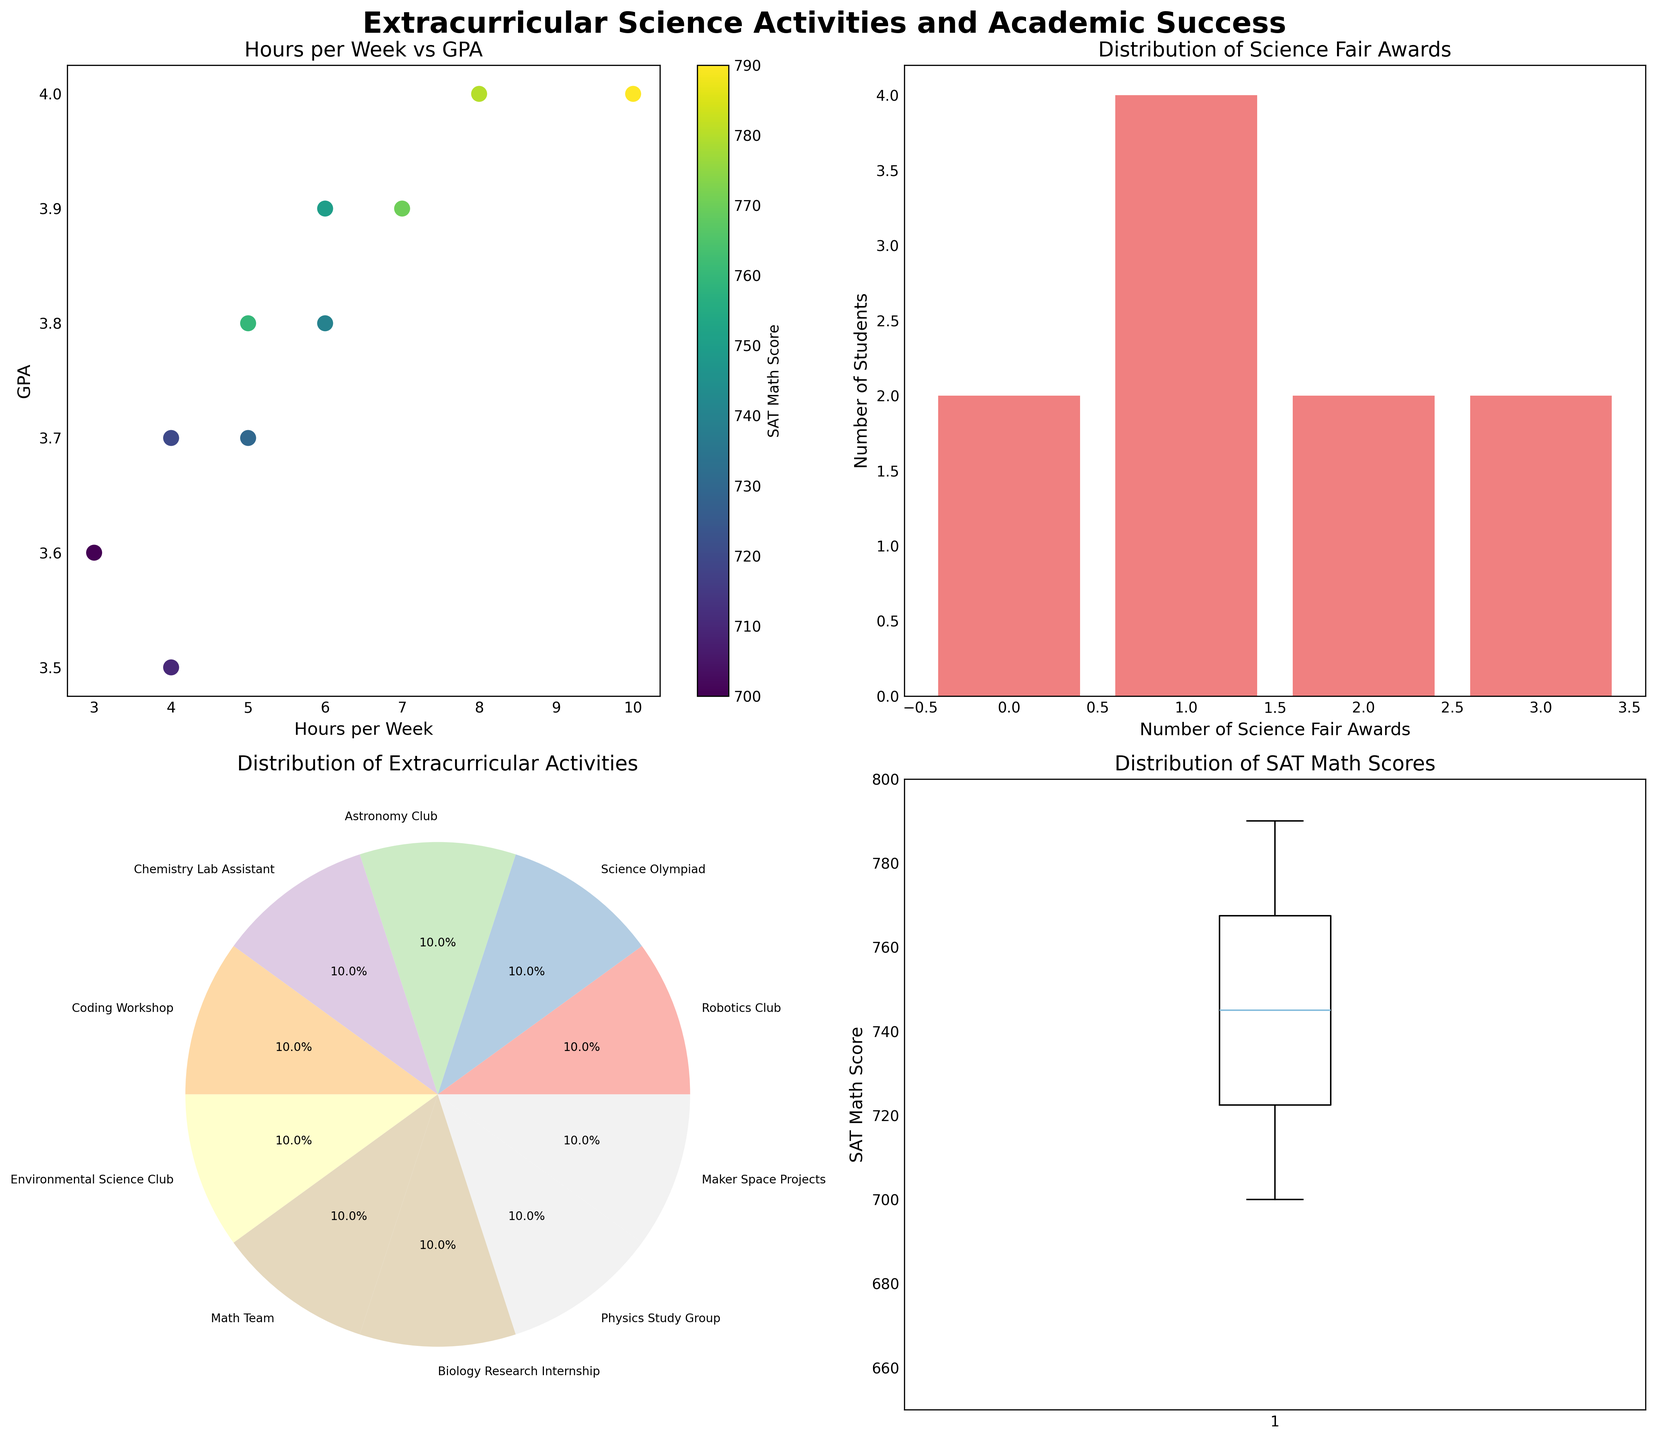What's the correlation between hours per week spent on activities and GPA? On the scatter plot (top-left), the x-axis represents hours per week and the y-axis represents GPA. As the number of hours per week increases, we observe a trend where GPA also tends to be high. The correlation appears to be positive.
Answer: Positive How many students have exactly 1 Science Fair Award? In the bar plot (top-right), count the bar corresponding to "1" on the x-axis. There are three students in this category.
Answer: 3 Which activity has the highest representation among students? In the pie chart (bottom-left), look for the segment with the largest area. The "Science Olympiad" has the greatest percentage.
Answer: Science Olympiad What's the range of SAT Math Scores in the data set? The box plot (bottom-right) shows the distribution of SAT Math Scores with the whiskers extending from the minimum to the maximum values. The range is from 700 to 790.
Answer: 700 to 790 Is there a student who spends significantly more hours per week on activities compared to others? In the scatter plot (top-left), look for the data point furthest to the right. Hannah, who spends 10 hours per week, is significantly above the others.
Answer: Yes What fraction of students have between 0 and 2 Science Fair Awards? In the bar plot (top-right), sum the counts for 0, 1, and 2 awards: \(2 + 3 + 3 = 8\). There are 10 students total, so the fraction is \( \frac{8}{10} \).
Answer: 0.8 or 80% What's the average SAT Math Score of the students? The box plot (bottom-right) suggests the SAT Math Scores distribution. By taking the approximate middle of the box plot, we estimate the mean around 750.
Answer: ~750 Which student has the highest GPA, and what is their extracurricular activity? In the scatter plot (top-left), the point located at GPA = 4.0 and colored for high SAT Math Scores corresponds to either Bob or Hannah; the pie chart confirms they are "Science Olympiad" and "Biology Research Internship" participants respectively.
Answer: Bob/Hannah, Science Olympiad/Biology Research Internship 